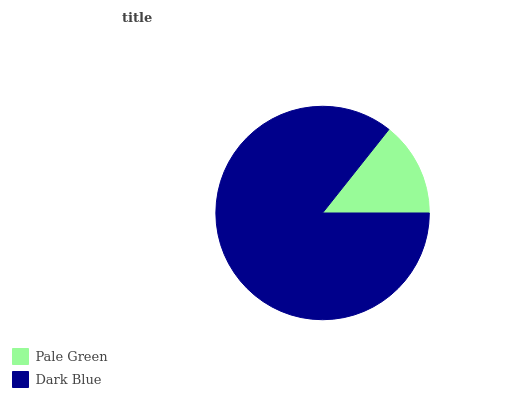Is Pale Green the minimum?
Answer yes or no. Yes. Is Dark Blue the maximum?
Answer yes or no. Yes. Is Dark Blue the minimum?
Answer yes or no. No. Is Dark Blue greater than Pale Green?
Answer yes or no. Yes. Is Pale Green less than Dark Blue?
Answer yes or no. Yes. Is Pale Green greater than Dark Blue?
Answer yes or no. No. Is Dark Blue less than Pale Green?
Answer yes or no. No. Is Dark Blue the high median?
Answer yes or no. Yes. Is Pale Green the low median?
Answer yes or no. Yes. Is Pale Green the high median?
Answer yes or no. No. Is Dark Blue the low median?
Answer yes or no. No. 